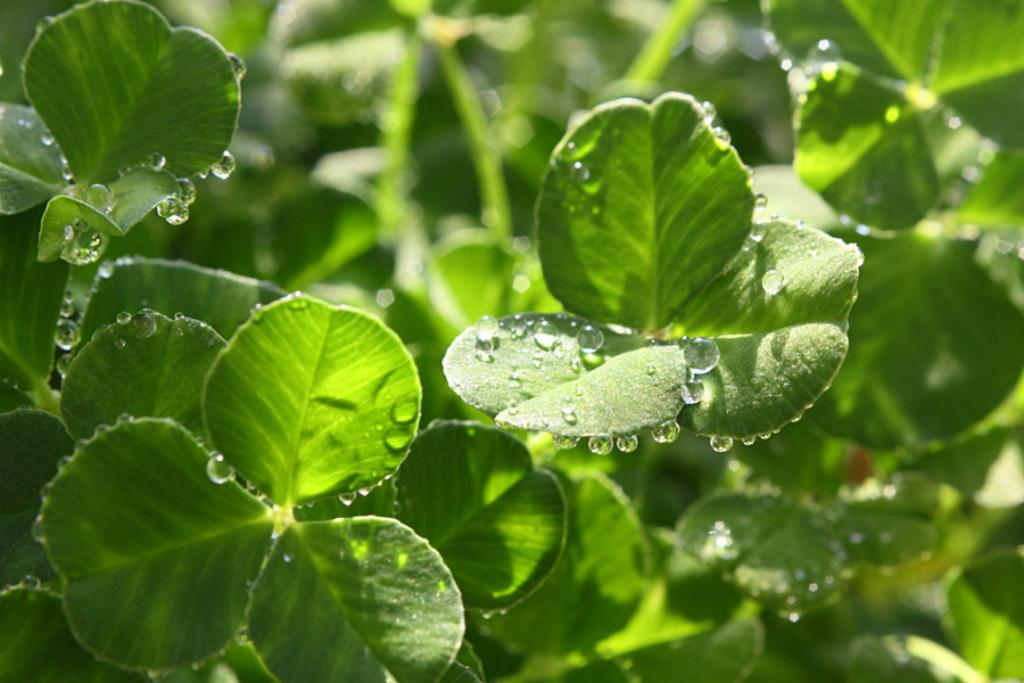What is the main subject of the image? The main subject of the image is leaves with water droplets. Can you describe the appearance of the water droplets? The water droplets appear to be on the leaves in the image. What can be observed about the background of the image? The background of the image is blurred. What type of payment is being made in the image? There is no payment being made in the image; it features leaves with water droplets and a blurred background. Can you describe the argument taking place in the image? There is no argument present in the image; it only shows leaves with water droplets and a blurred background. 